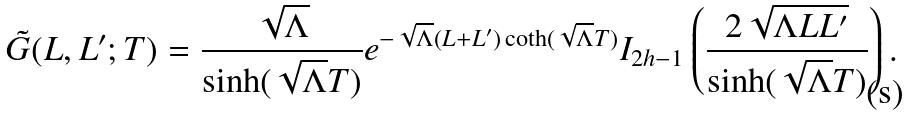Convert formula to latex. <formula><loc_0><loc_0><loc_500><loc_500>\tilde { G } ( L , L ^ { \prime } ; T ) = \frac { \sqrt { \Lambda } } { \sinh ( \sqrt { \Lambda } T ) } e ^ { - \sqrt { \Lambda } ( L + L ^ { \prime } ) \coth ( \sqrt { \Lambda } T ) } I _ { 2 h - 1 } \left ( \frac { 2 \sqrt { \Lambda L L ^ { \prime } } } { \sinh ( \sqrt { \Lambda } T ) } \right ) .</formula> 